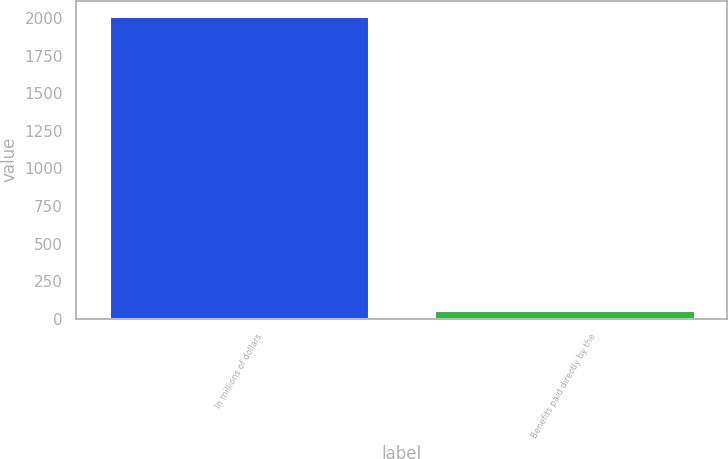Convert chart. <chart><loc_0><loc_0><loc_500><loc_500><bar_chart><fcel>In millions of dollars<fcel>Benefits paid directly by the<nl><fcel>2017<fcel>55<nl></chart> 